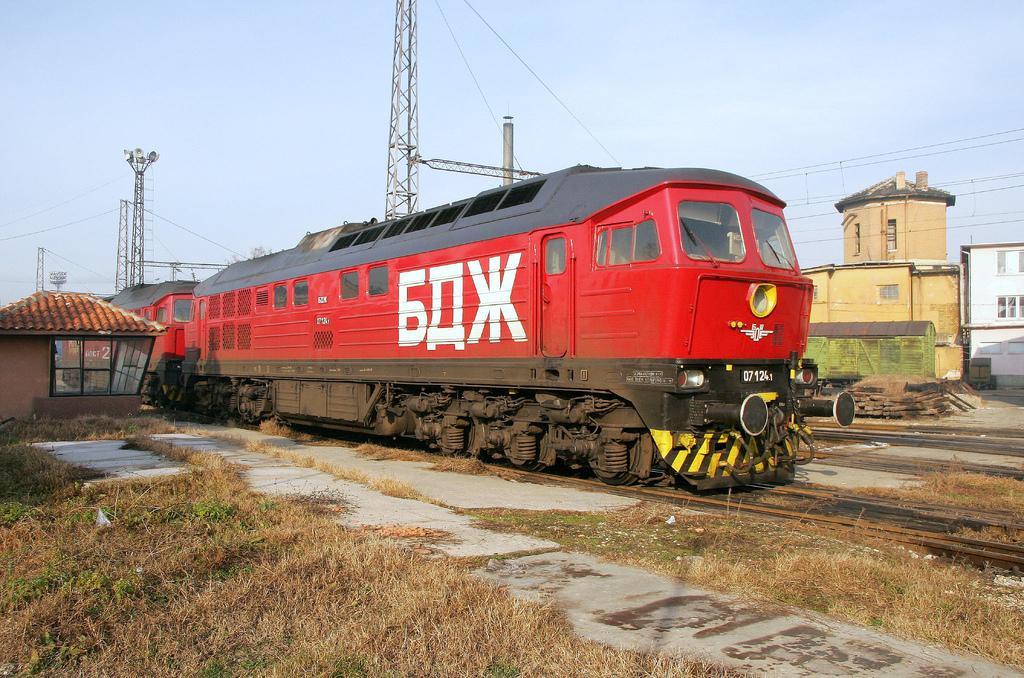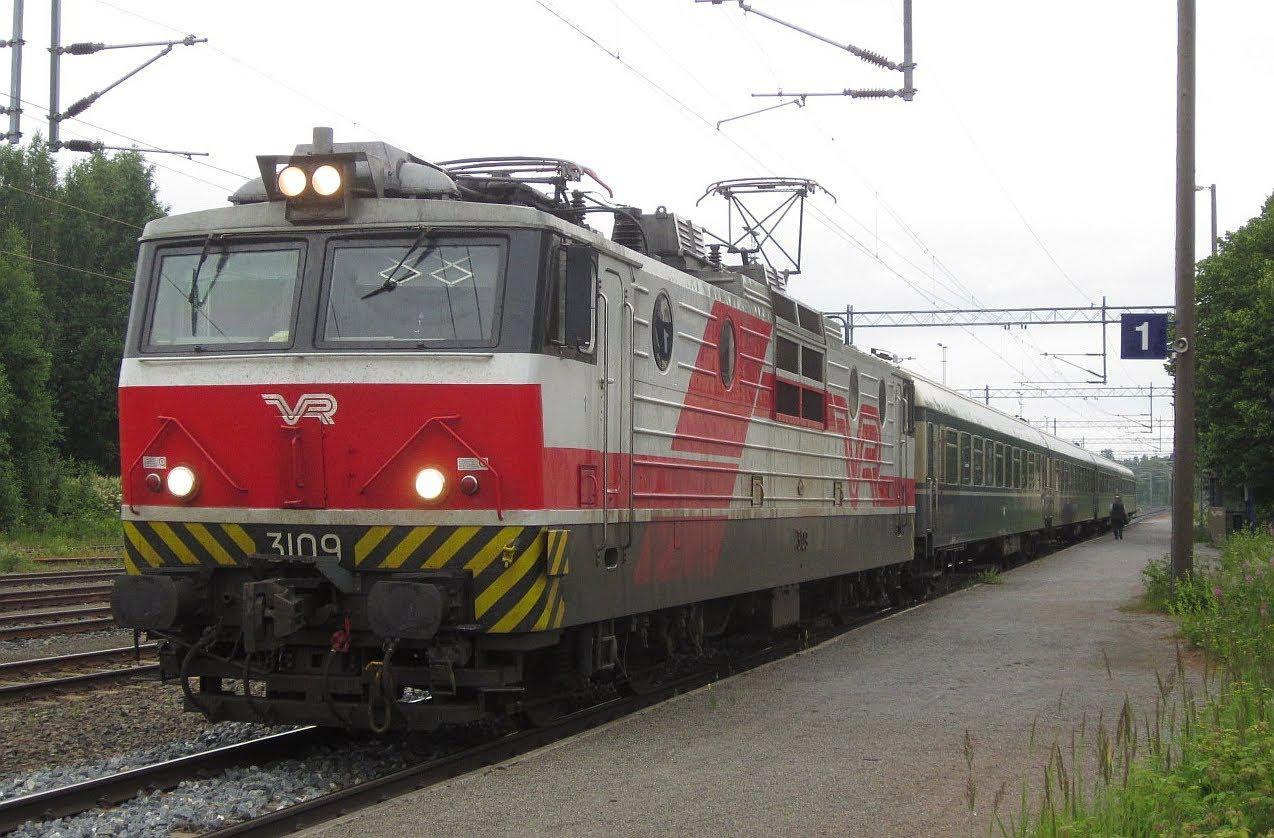The first image is the image on the left, the second image is the image on the right. For the images shown, is this caption "Each image shows a predominantly orange-red train, and no train has its front aimed leftward." true? Answer yes or no. No. The first image is the image on the left, the second image is the image on the right. Examine the images to the left and right. Is the description "Both trains are predominately red headed in the same direction." accurate? Answer yes or no. No. 